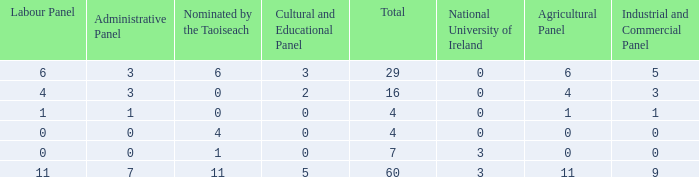What is the total number of agriculatural panels of the composition with more than 3 National Universities of Ireland? 0.0. 